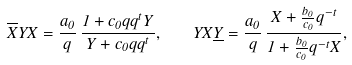Convert formula to latex. <formula><loc_0><loc_0><loc_500><loc_500>\overline { X } Y X = \frac { a _ { 0 } } { q } \, \frac { 1 + c _ { 0 } q q ^ { t } Y } { Y + c _ { 0 } q q ^ { t } } , \quad Y X \underline { Y } = \frac { a _ { 0 } } { q } \, \frac { X + \frac { b _ { 0 } } { c _ { 0 } } q ^ { - t } } { 1 + \frac { b _ { 0 } } { c _ { 0 } } q ^ { - t } X } ,</formula> 